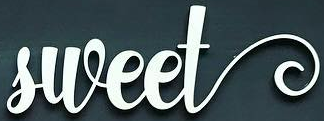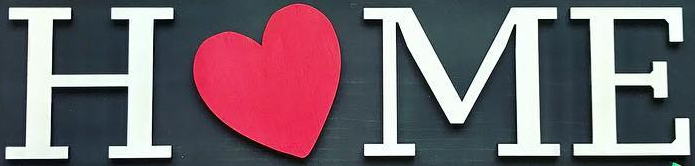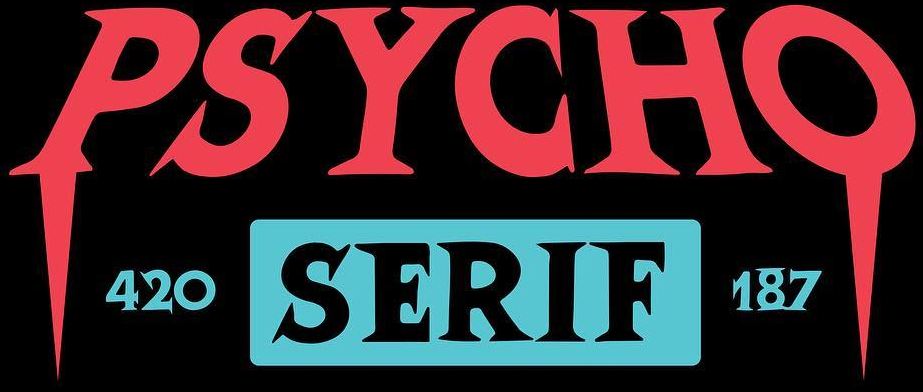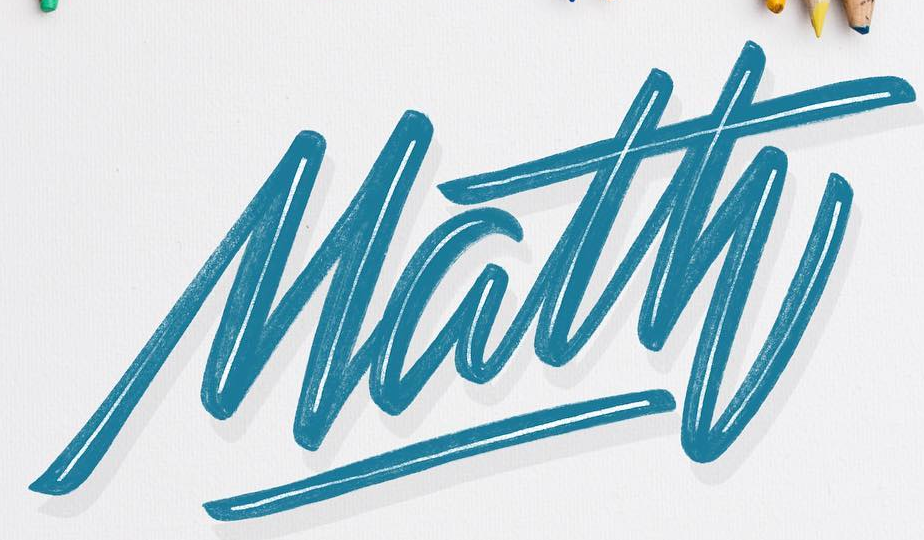What text appears in these images from left to right, separated by a semicolon? sweet; HOME; PSYCHO; Math 